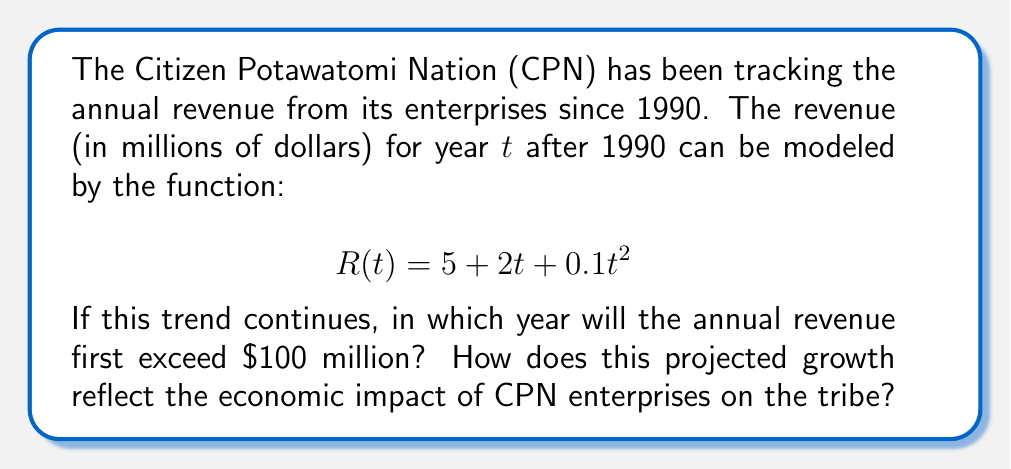Can you solve this math problem? To solve this problem, we need to find the value of $t$ where $R(t)$ exceeds 100 million dollars. Let's approach this step-by-step:

1) We start with the equation:
   $$R(t) = 5 + 2t + 0.1t^2$$

2) We want to find $t$ when $R(t) > 100$:
   $$5 + 2t + 0.1t^2 > 100$$

3) Rearranging the inequality:
   $$0.1t^2 + 2t - 95 > 0$$

4) This is a quadratic inequality. To solve it, we first find the roots of the corresponding quadratic equation:
   $$0.1t^2 + 2t - 95 = 0$$

5) Using the quadratic formula $\frac{-b \pm \sqrt{b^2 - 4ac}}{2a}$:
   $$t = \frac{-2 \pm \sqrt{4 - 4(0.1)(-95)}}{2(0.1)}$$
   $$= \frac{-2 \pm \sqrt{4 + 38}}{0.2}$$
   $$= \frac{-2 \pm \sqrt{42}}{0.2}$$

6) Simplifying:
   $$t \approx 8.24 \text{ or } t \approx -28.24$$

7) Since time can't be negative in this context, we consider only the positive root. The revenue will exceed $100 million when $t > 8.24$.

8) Since $t$ represents years after 1990, and we need the first whole year where this occurs, we round up to 9.

9) Therefore, the revenue will first exceed $100 million in the 9th year after 1990, which is 1999.

This projected growth reflects a significant positive economic impact of CPN enterprises on the tribe. Starting from a relatively modest revenue of $5 million in 1990, the enterprises are projected to generate over $100 million annually within just 9 years. The quadratic nature of the growth (${0.1t^2}$ term) suggests accelerating returns, indicating that the tribe's investments are not only profitable but increasingly so over time.
Answer: The annual revenue will first exceed $100 million in 1999, which is 9 years after 1990. 